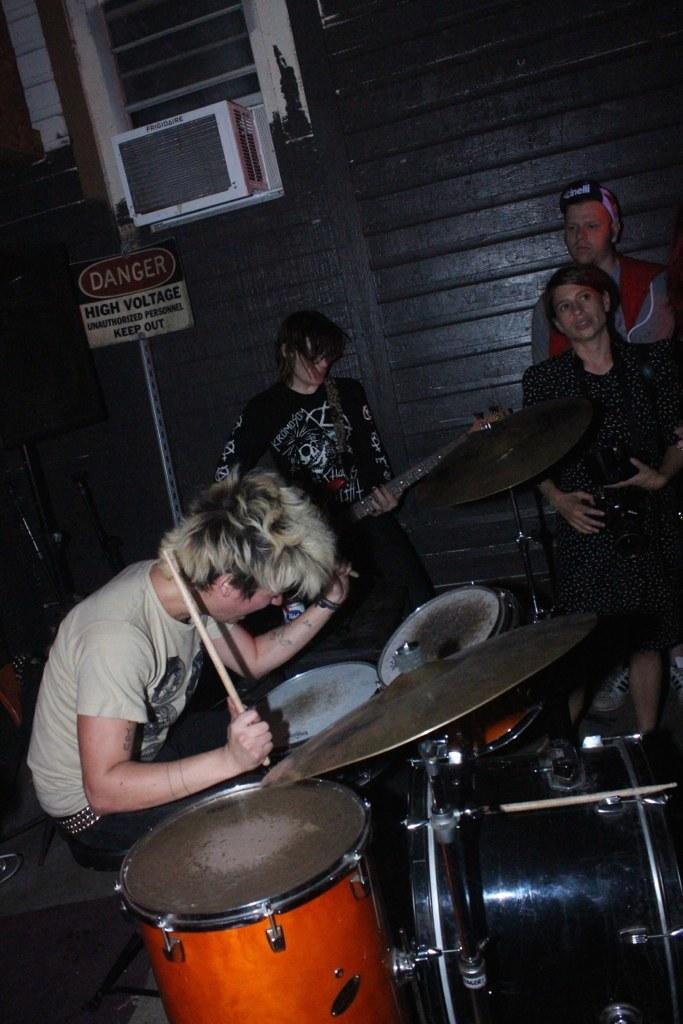In one or two sentences, can you explain what this image depicts? In this picture, There are some music instruments which are in black and yellow color, There are some people siting on the chairs, In the left side there is a boy sitting and holding a stick which is in yellow color, In the background there is a black color wall. 